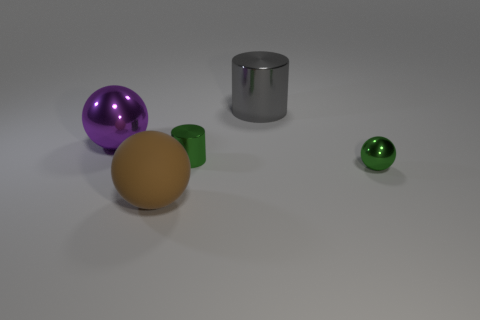Add 3 gray rubber objects. How many objects exist? 8 Subtract all spheres. How many objects are left? 2 Subtract all small yellow spheres. Subtract all gray shiny cylinders. How many objects are left? 4 Add 4 brown matte spheres. How many brown matte spheres are left? 5 Add 3 green cylinders. How many green cylinders exist? 4 Subtract 1 gray cylinders. How many objects are left? 4 